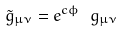Convert formula to latex. <formula><loc_0><loc_0><loc_500><loc_500>\tilde { g } _ { \mu \nu } = e ^ { c \phi } \ g _ { \mu \nu }</formula> 